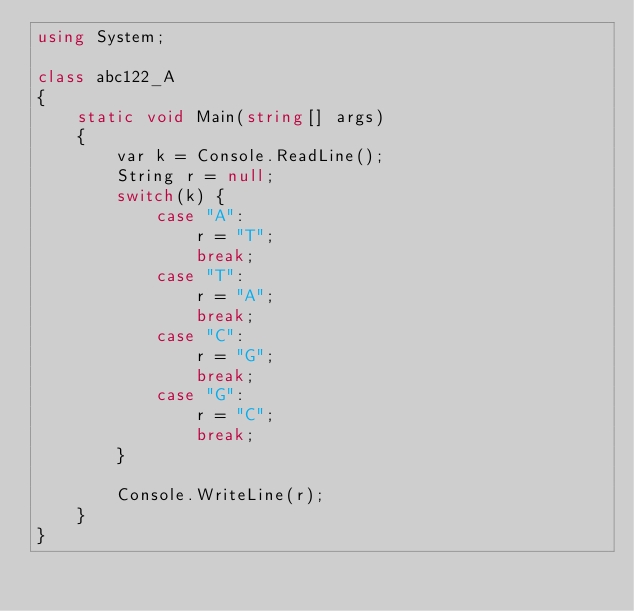Convert code to text. <code><loc_0><loc_0><loc_500><loc_500><_C#_>using System;

class abc122_A
{
    static void Main(string[] args)
    {
        var k = Console.ReadLine();
        String r = null;
        switch(k) {
            case "A":
                r = "T";
                break;
            case "T":
                r = "A";
                break;
            case "C":
                r = "G";
                break;
            case "G":
                r = "C";
                break;
        }

        Console.WriteLine(r);
    }
}</code> 